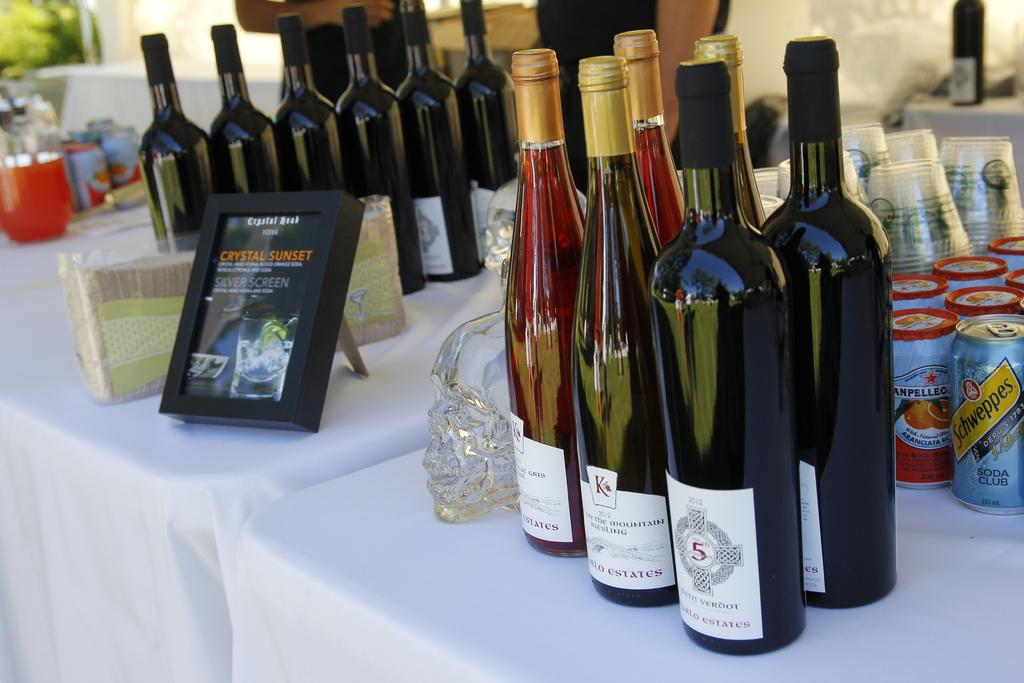<image>
Share a concise interpretation of the image provided. Many bottles of wine on a table with a framed picture that says Crystal Sunset. 